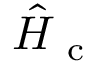<formula> <loc_0><loc_0><loc_500><loc_500>\hat { H } _ { c }</formula> 